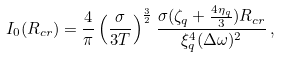<formula> <loc_0><loc_0><loc_500><loc_500>I _ { 0 } ( R _ { c r } ) = \frac { 4 } { \pi } \left ( \frac { \sigma } { 3 T } \right ) ^ { \frac { 3 } { 2 } } \frac { \sigma ( \zeta _ { q } + \frac { 4 \eta _ { q } } { 3 } ) R _ { c r } } { \xi _ { q } ^ { 4 } ( \Delta \omega ) ^ { 2 } } \, ,</formula> 